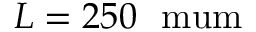<formula> <loc_0><loc_0><loc_500><loc_500>L = 2 5 0 \ m u m</formula> 